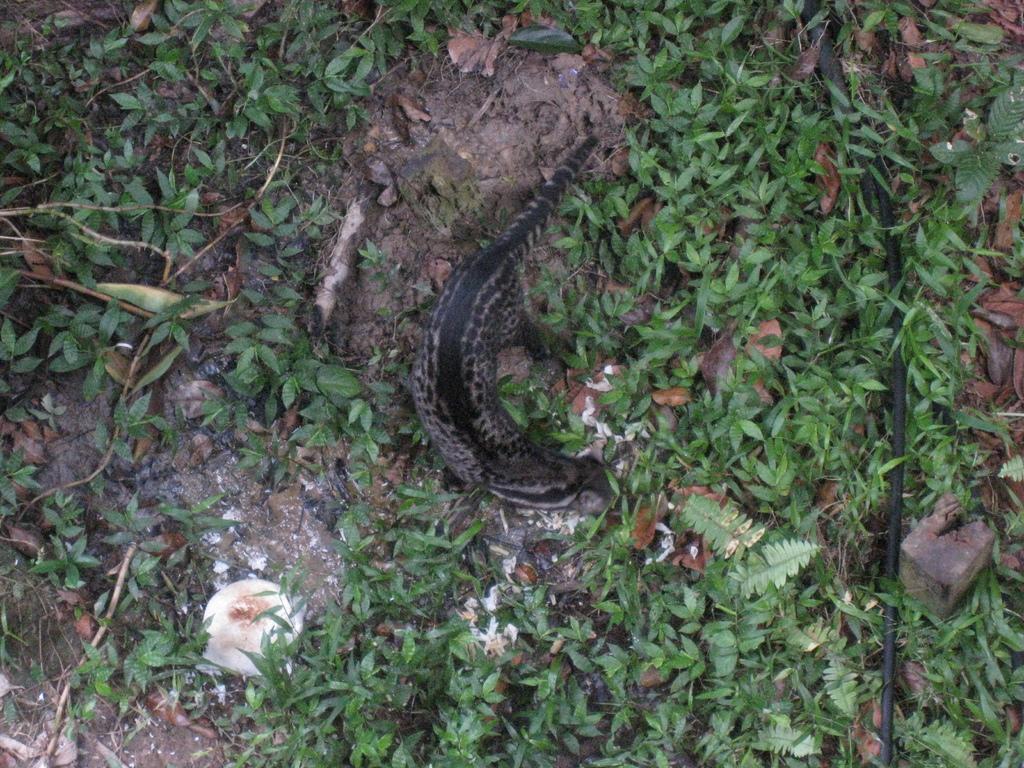Can you describe this image briefly? In this image, I can see an alligator lizard on grass. This image is taken, maybe during a day. 